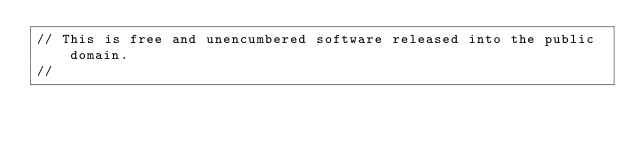<code> <loc_0><loc_0><loc_500><loc_500><_Scala_>// This is free and unencumbered software released into the public domain.
//</code> 